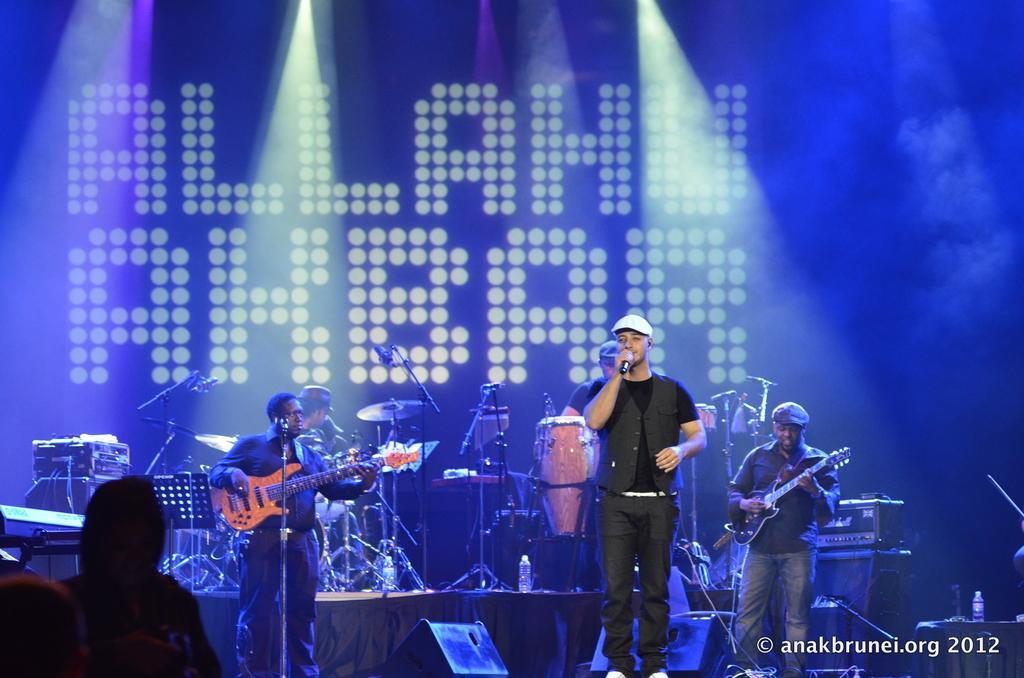How would you summarize this image in a sentence or two? In the picture we can find some persons are standing, two are holding a guitars and one person is singing. In the front of them they are some persons sitting on the chairs. In the background we can find a wall with the wordings 'Allahu Akbar'. And some lights. And we can also find some musical instruments, drums, stand, sticks and some music boxes. 